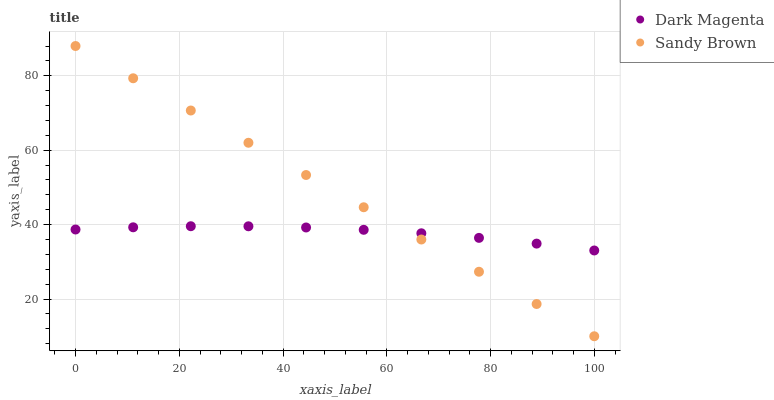Does Dark Magenta have the minimum area under the curve?
Answer yes or no. Yes. Does Sandy Brown have the maximum area under the curve?
Answer yes or no. Yes. Does Dark Magenta have the maximum area under the curve?
Answer yes or no. No. Is Sandy Brown the smoothest?
Answer yes or no. Yes. Is Dark Magenta the roughest?
Answer yes or no. Yes. Is Dark Magenta the smoothest?
Answer yes or no. No. Does Sandy Brown have the lowest value?
Answer yes or no. Yes. Does Dark Magenta have the lowest value?
Answer yes or no. No. Does Sandy Brown have the highest value?
Answer yes or no. Yes. Does Dark Magenta have the highest value?
Answer yes or no. No. Does Dark Magenta intersect Sandy Brown?
Answer yes or no. Yes. Is Dark Magenta less than Sandy Brown?
Answer yes or no. No. Is Dark Magenta greater than Sandy Brown?
Answer yes or no. No. 